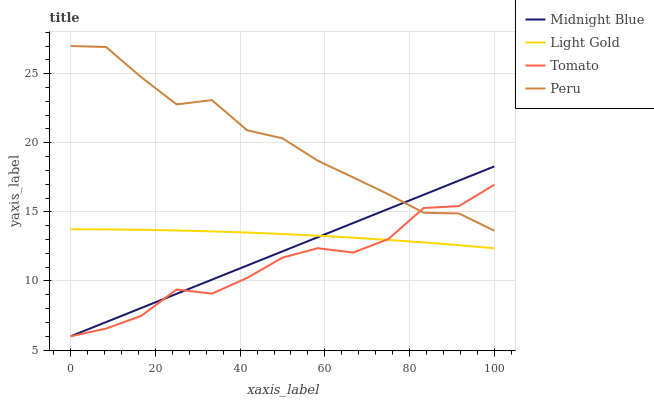Does Tomato have the minimum area under the curve?
Answer yes or no. Yes. Does Peru have the maximum area under the curve?
Answer yes or no. Yes. Does Light Gold have the minimum area under the curve?
Answer yes or no. No. Does Light Gold have the maximum area under the curve?
Answer yes or no. No. Is Midnight Blue the smoothest?
Answer yes or no. Yes. Is Tomato the roughest?
Answer yes or no. Yes. Is Light Gold the smoothest?
Answer yes or no. No. Is Light Gold the roughest?
Answer yes or no. No. Does Tomato have the lowest value?
Answer yes or no. Yes. Does Light Gold have the lowest value?
Answer yes or no. No. Does Peru have the highest value?
Answer yes or no. Yes. Does Midnight Blue have the highest value?
Answer yes or no. No. Is Light Gold less than Peru?
Answer yes or no. Yes. Is Peru greater than Light Gold?
Answer yes or no. Yes. Does Peru intersect Midnight Blue?
Answer yes or no. Yes. Is Peru less than Midnight Blue?
Answer yes or no. No. Is Peru greater than Midnight Blue?
Answer yes or no. No. Does Light Gold intersect Peru?
Answer yes or no. No. 